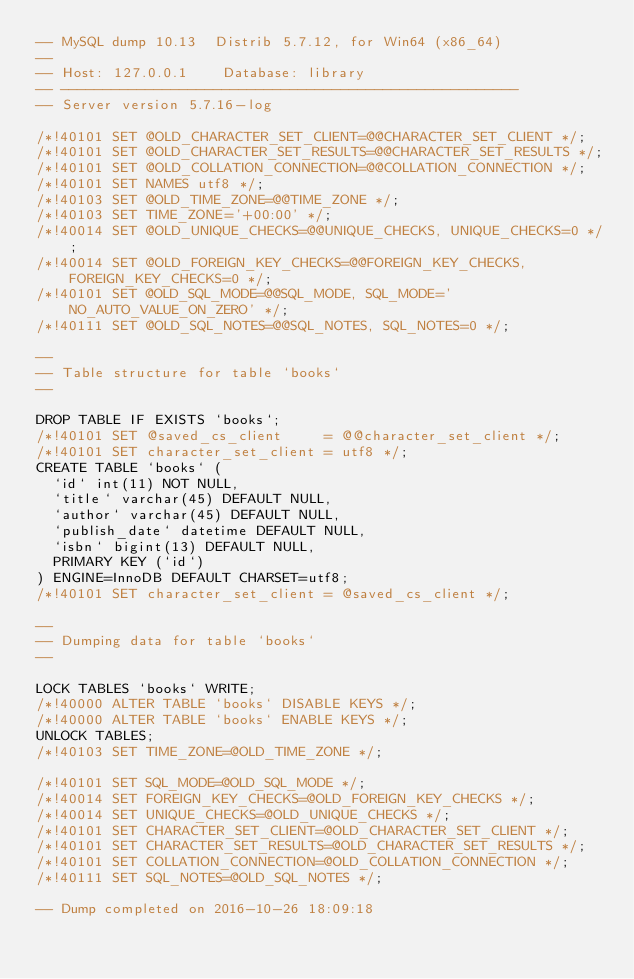<code> <loc_0><loc_0><loc_500><loc_500><_SQL_>-- MySQL dump 10.13  Distrib 5.7.12, for Win64 (x86_64)
--
-- Host: 127.0.0.1    Database: library
-- ------------------------------------------------------
-- Server version	5.7.16-log

/*!40101 SET @OLD_CHARACTER_SET_CLIENT=@@CHARACTER_SET_CLIENT */;
/*!40101 SET @OLD_CHARACTER_SET_RESULTS=@@CHARACTER_SET_RESULTS */;
/*!40101 SET @OLD_COLLATION_CONNECTION=@@COLLATION_CONNECTION */;
/*!40101 SET NAMES utf8 */;
/*!40103 SET @OLD_TIME_ZONE=@@TIME_ZONE */;
/*!40103 SET TIME_ZONE='+00:00' */;
/*!40014 SET @OLD_UNIQUE_CHECKS=@@UNIQUE_CHECKS, UNIQUE_CHECKS=0 */;
/*!40014 SET @OLD_FOREIGN_KEY_CHECKS=@@FOREIGN_KEY_CHECKS, FOREIGN_KEY_CHECKS=0 */;
/*!40101 SET @OLD_SQL_MODE=@@SQL_MODE, SQL_MODE='NO_AUTO_VALUE_ON_ZERO' */;
/*!40111 SET @OLD_SQL_NOTES=@@SQL_NOTES, SQL_NOTES=0 */;

--
-- Table structure for table `books`
--

DROP TABLE IF EXISTS `books`;
/*!40101 SET @saved_cs_client     = @@character_set_client */;
/*!40101 SET character_set_client = utf8 */;
CREATE TABLE `books` (
  `id` int(11) NOT NULL,
  `title` varchar(45) DEFAULT NULL,
  `author` varchar(45) DEFAULT NULL,
  `publish_date` datetime DEFAULT NULL,
  `isbn` bigint(13) DEFAULT NULL,
  PRIMARY KEY (`id`)
) ENGINE=InnoDB DEFAULT CHARSET=utf8;
/*!40101 SET character_set_client = @saved_cs_client */;

--
-- Dumping data for table `books`
--

LOCK TABLES `books` WRITE;
/*!40000 ALTER TABLE `books` DISABLE KEYS */;
/*!40000 ALTER TABLE `books` ENABLE KEYS */;
UNLOCK TABLES;
/*!40103 SET TIME_ZONE=@OLD_TIME_ZONE */;

/*!40101 SET SQL_MODE=@OLD_SQL_MODE */;
/*!40014 SET FOREIGN_KEY_CHECKS=@OLD_FOREIGN_KEY_CHECKS */;
/*!40014 SET UNIQUE_CHECKS=@OLD_UNIQUE_CHECKS */;
/*!40101 SET CHARACTER_SET_CLIENT=@OLD_CHARACTER_SET_CLIENT */;
/*!40101 SET CHARACTER_SET_RESULTS=@OLD_CHARACTER_SET_RESULTS */;
/*!40101 SET COLLATION_CONNECTION=@OLD_COLLATION_CONNECTION */;
/*!40111 SET SQL_NOTES=@OLD_SQL_NOTES */;

-- Dump completed on 2016-10-26 18:09:18
</code> 